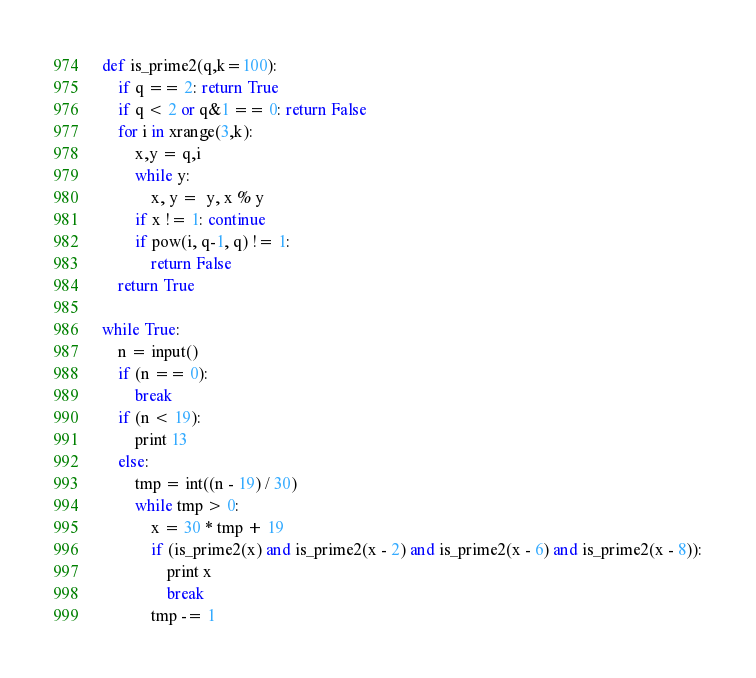<code> <loc_0><loc_0><loc_500><loc_500><_Python_>
def is_prime2(q,k=100):
    if q == 2: return True
    if q < 2 or q&1 == 0: return False
    for i in xrange(3,k):
        x,y = q,i
        while y:
            x, y =  y, x % y
        if x != 1: continue
        if pow(i, q-1, q) != 1:
            return False
    return True

while True:
    n = input()
    if (n == 0):
        break
    if (n < 19):
        print 13
    else:
        tmp = int((n - 19) / 30)
        while tmp > 0:
            x = 30 * tmp + 19
            if (is_prime2(x) and is_prime2(x - 2) and is_prime2(x - 6) and is_prime2(x - 8)):
                print x
                break
            tmp -= 1</code> 